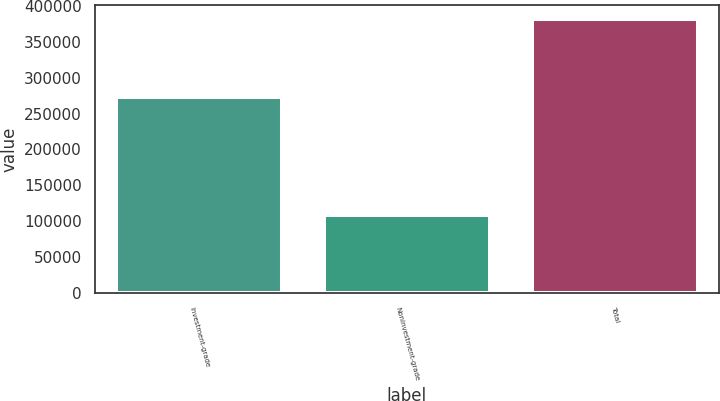Convert chart to OTSL. <chart><loc_0><loc_0><loc_500><loc_500><bar_chart><fcel>Investment-grade<fcel>Noninvestment-grade<fcel>Total<nl><fcel>273688<fcel>107955<fcel>381643<nl></chart> 